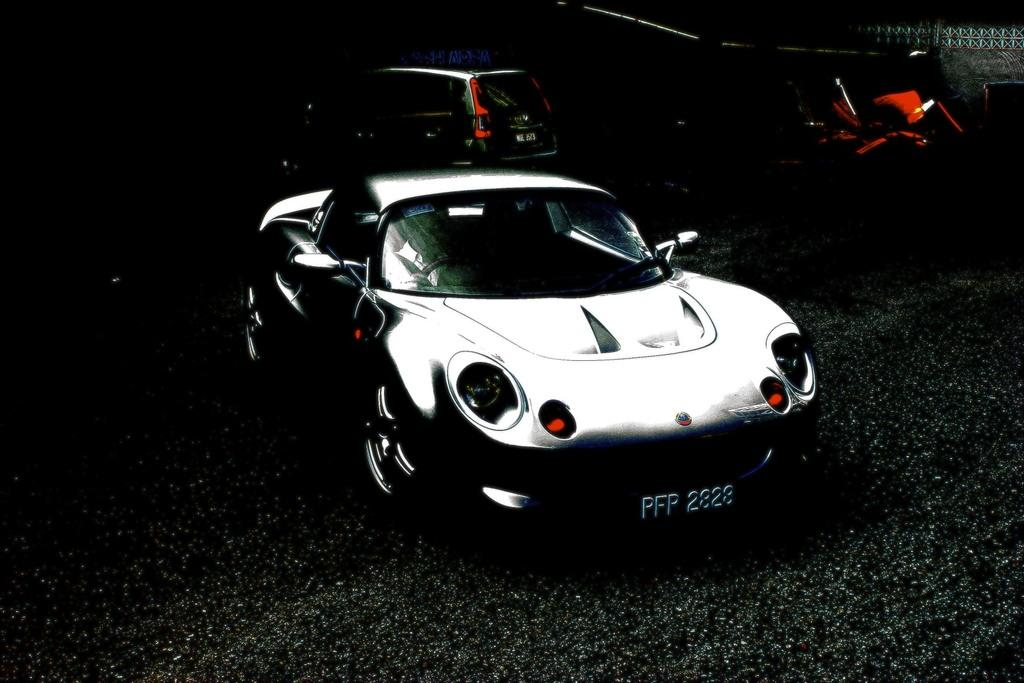How many cars can be seen in the image? There are two cars in the image. What part of one of the cars is visible in the image? The number plate of one car is visible. What material is the car made of, which is visible in the image? The glass of the car is visible in the image. What part of the car is used for illumination, and is visible in the image? The lights of the car are visible in the image. What surface can be seen at the bottom of the image? There is a road at the bottom of the image. What type of lip can be seen on the car in the image? There is no lip present on the car in the image. Is there a sheet covering the cars in the image? There is no sheet covering the cars in the image. 